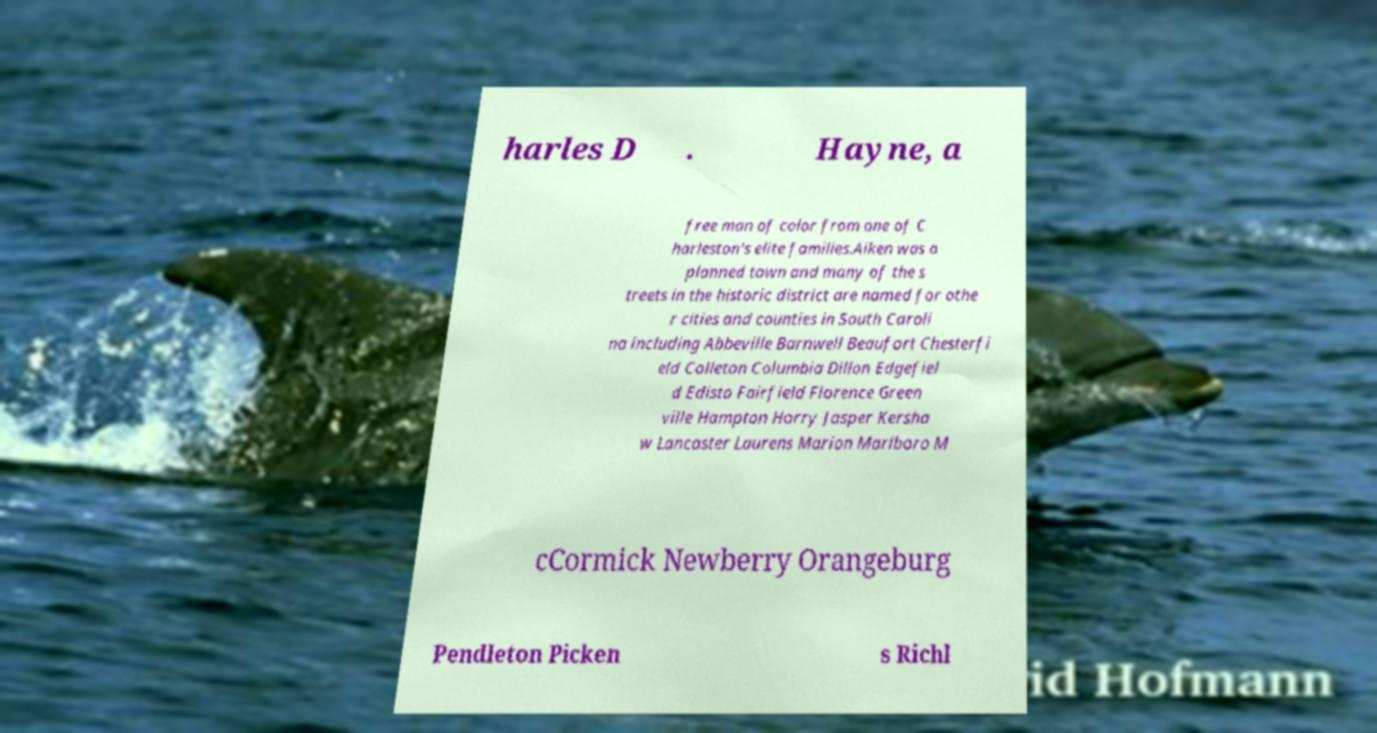Please identify and transcribe the text found in this image. harles D . Hayne, a free man of color from one of C harleston's elite families.Aiken was a planned town and many of the s treets in the historic district are named for othe r cities and counties in South Caroli na including Abbeville Barnwell Beaufort Chesterfi eld Colleton Columbia Dillon Edgefiel d Edisto Fairfield Florence Green ville Hampton Horry Jasper Kersha w Lancaster Laurens Marion Marlboro M cCormick Newberry Orangeburg Pendleton Picken s Richl 